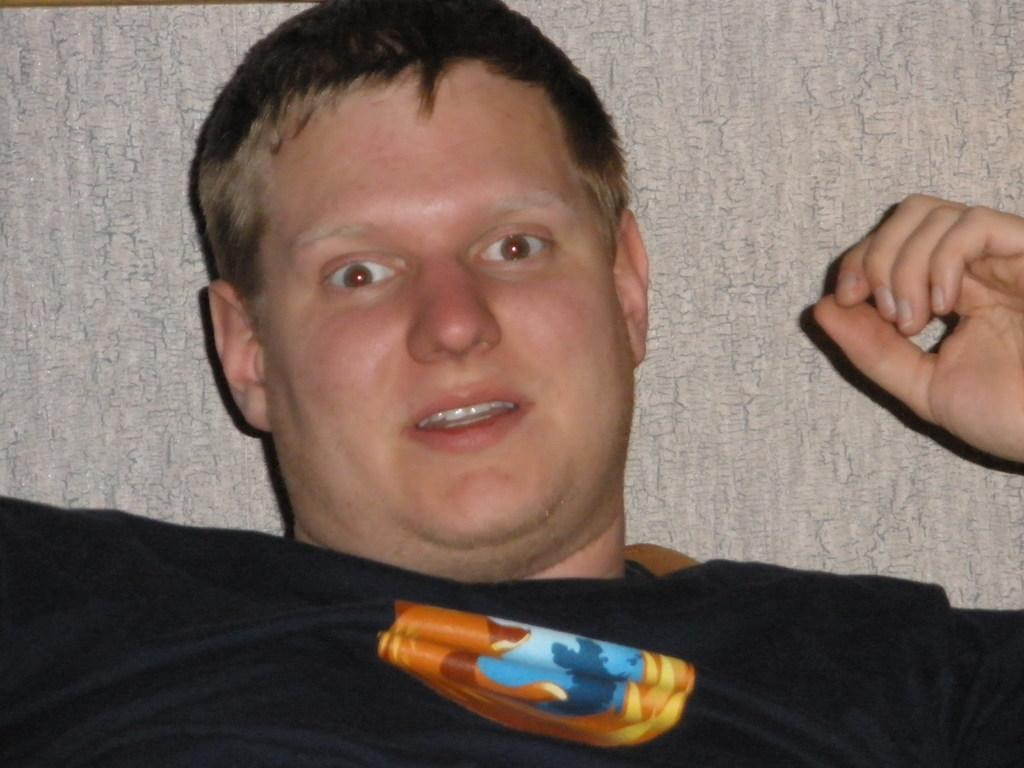What is present in the image? There is a person in the image. What is the person wearing? The person is wearing a black t-shirt. What type of tin can be seen in the person's hand in the image? There is no tin present in the image; the person is wearing a black t-shirt. How does the butter look like in the image? There is no butter present in the image; the person is wearing a black t-shirt. 